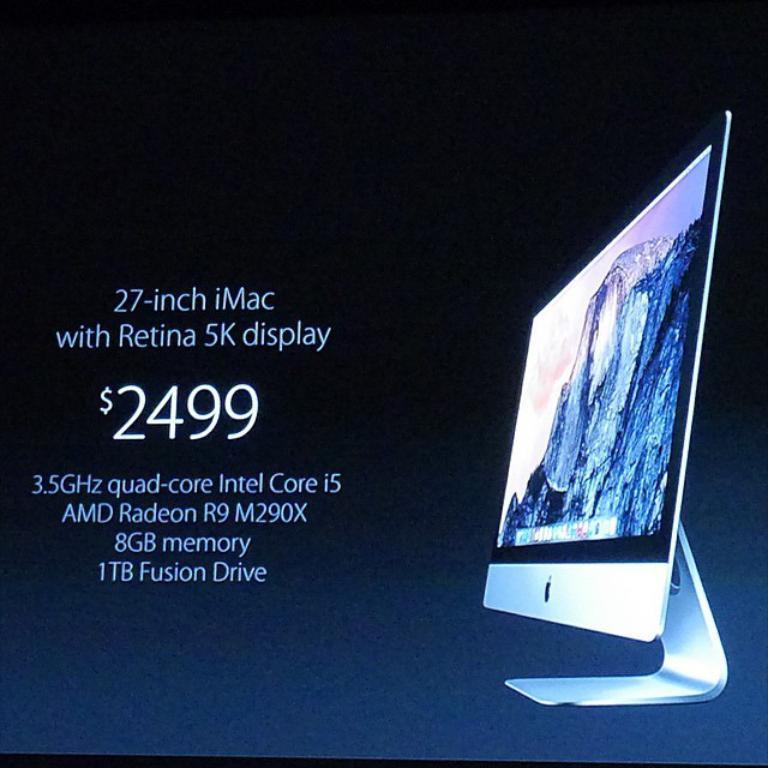<image>
Share a concise interpretation of the image provided. Imac computer with Retina 5k display for sale 